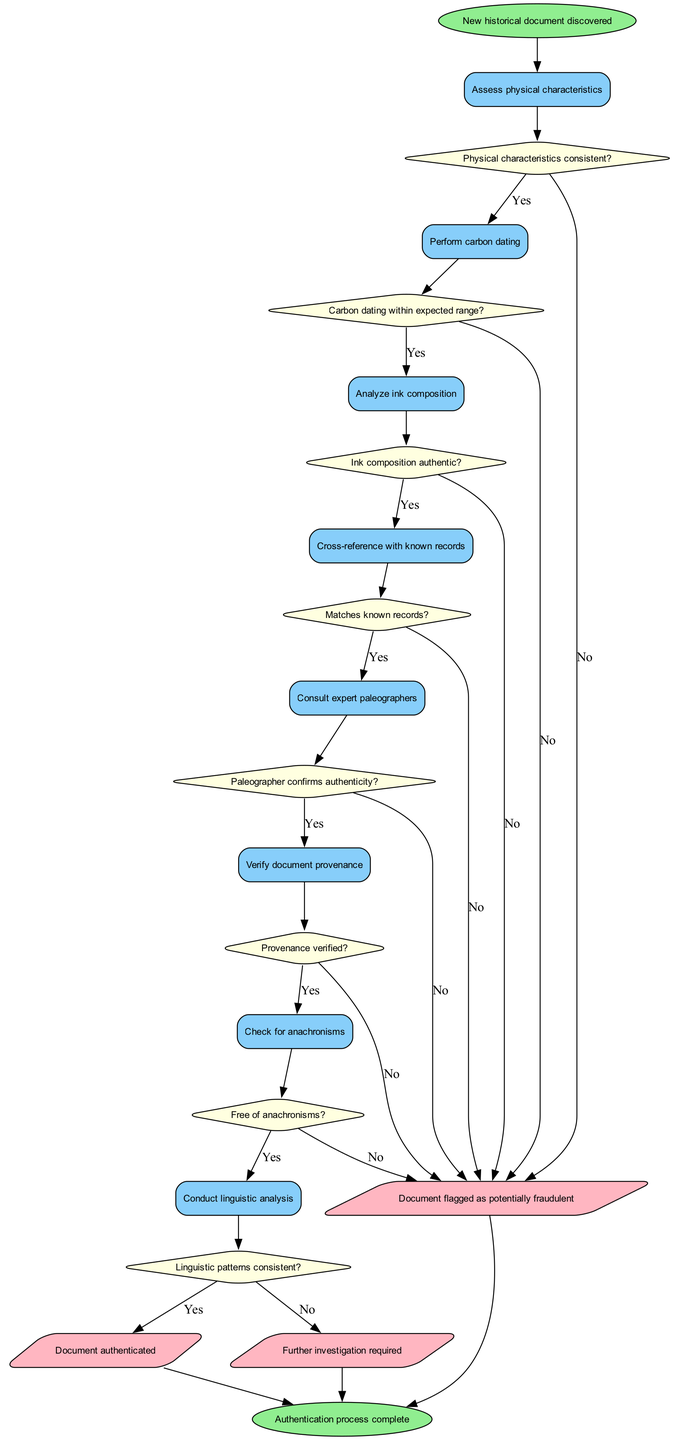What is the first process in the diagram? The first process node, directly following the start node, is labeled "Assess physical characteristics." Therefore, it serves as the initial step in the authentication process.
Answer: Assess physical characteristics How many decision nodes are there in the diagram? The diagram contains eight decision nodes, as specified in the list of decisions included in the structure of the flowchart. Each decision corresponds to a question about the document's authenticity.
Answer: Eight What happens if the carbon dating is outside the expected range? If the carbon dating is not within the expected range, the flow directs to the output indicating that the document is flagged as potentially fraudulent. This follows from the "Carbon dating within expected range?" decision node's "No" path.
Answer: Document flagged as potentially fraudulent Which process follows the decision about the ink composition? After the "Ink composition authentic?" decision node, the process that follows if the answer is "Yes" is labeled "Cross-reference with known records." This progression illustrates the flow of steps toward authenticating the document.
Answer: Cross-reference with known records What is the final output of the process if all decisions lead to "Yes"? If all decisions lead to "Yes," the final output of the process will be "Document authenticated." This outcome shows that the document is considered genuinely authentic based on the verification steps.
Answer: Document authenticated 